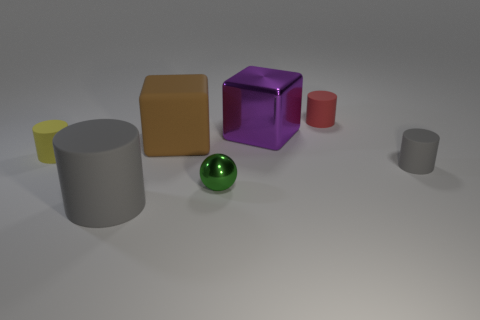Subtract all blue cylinders. Subtract all green spheres. How many cylinders are left? 4 Add 2 brown shiny blocks. How many objects exist? 9 Subtract all spheres. How many objects are left? 6 Subtract 0 brown cylinders. How many objects are left? 7 Subtract all gray rubber objects. Subtract all tiny matte things. How many objects are left? 2 Add 1 small green metal things. How many small green metal things are left? 2 Add 6 cyan matte cylinders. How many cyan matte cylinders exist? 6 